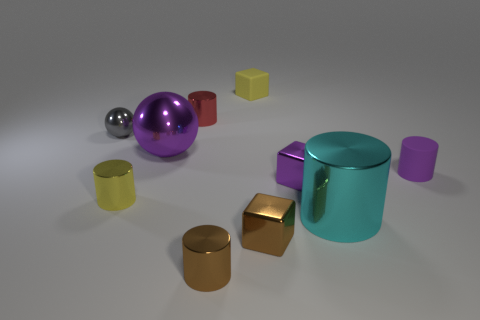Subtract 1 cylinders. How many cylinders are left? 4 Subtract all yellow cylinders. How many cylinders are left? 4 Subtract all large cylinders. How many cylinders are left? 4 Subtract all blue cylinders. Subtract all purple cubes. How many cylinders are left? 5 Subtract all blocks. How many objects are left? 7 Add 6 purple shiny objects. How many purple shiny objects are left? 8 Add 7 tiny yellow matte cubes. How many tiny yellow matte cubes exist? 8 Subtract 1 yellow cylinders. How many objects are left? 9 Subtract all gray objects. Subtract all gray shiny objects. How many objects are left? 8 